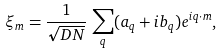<formula> <loc_0><loc_0><loc_500><loc_500>\xi _ { m } = \frac { 1 } { \sqrt { D N } } \, \sum _ { q } ( a _ { q } + i b _ { q } ) e ^ { i { q \cdot m } } ,</formula> 